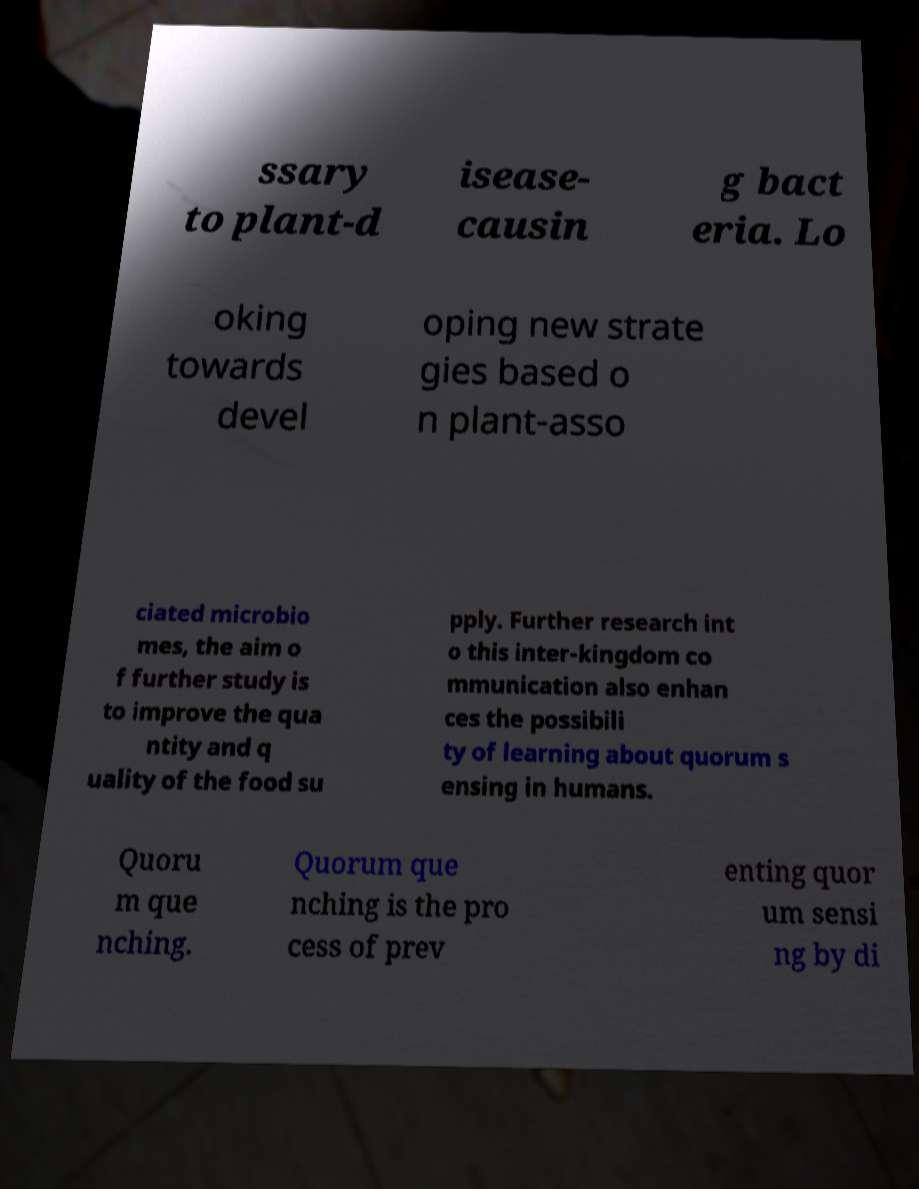Please read and relay the text visible in this image. What does it say? ssary to plant-d isease- causin g bact eria. Lo oking towards devel oping new strate gies based o n plant-asso ciated microbio mes, the aim o f further study is to improve the qua ntity and q uality of the food su pply. Further research int o this inter-kingdom co mmunication also enhan ces the possibili ty of learning about quorum s ensing in humans. Quoru m que nching. Quorum que nching is the pro cess of prev enting quor um sensi ng by di 